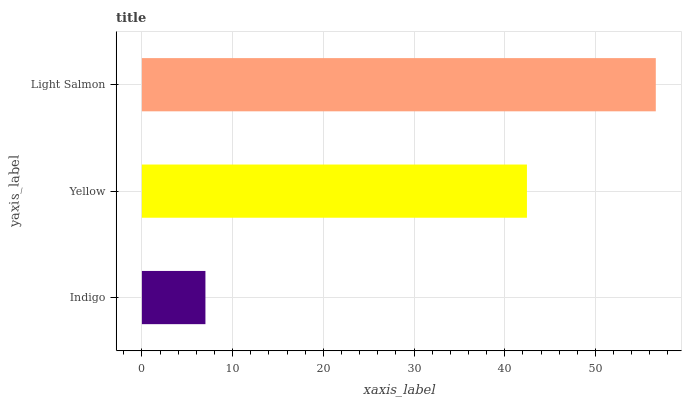Is Indigo the minimum?
Answer yes or no. Yes. Is Light Salmon the maximum?
Answer yes or no. Yes. Is Yellow the minimum?
Answer yes or no. No. Is Yellow the maximum?
Answer yes or no. No. Is Yellow greater than Indigo?
Answer yes or no. Yes. Is Indigo less than Yellow?
Answer yes or no. Yes. Is Indigo greater than Yellow?
Answer yes or no. No. Is Yellow less than Indigo?
Answer yes or no. No. Is Yellow the high median?
Answer yes or no. Yes. Is Yellow the low median?
Answer yes or no. Yes. Is Indigo the high median?
Answer yes or no. No. Is Light Salmon the low median?
Answer yes or no. No. 